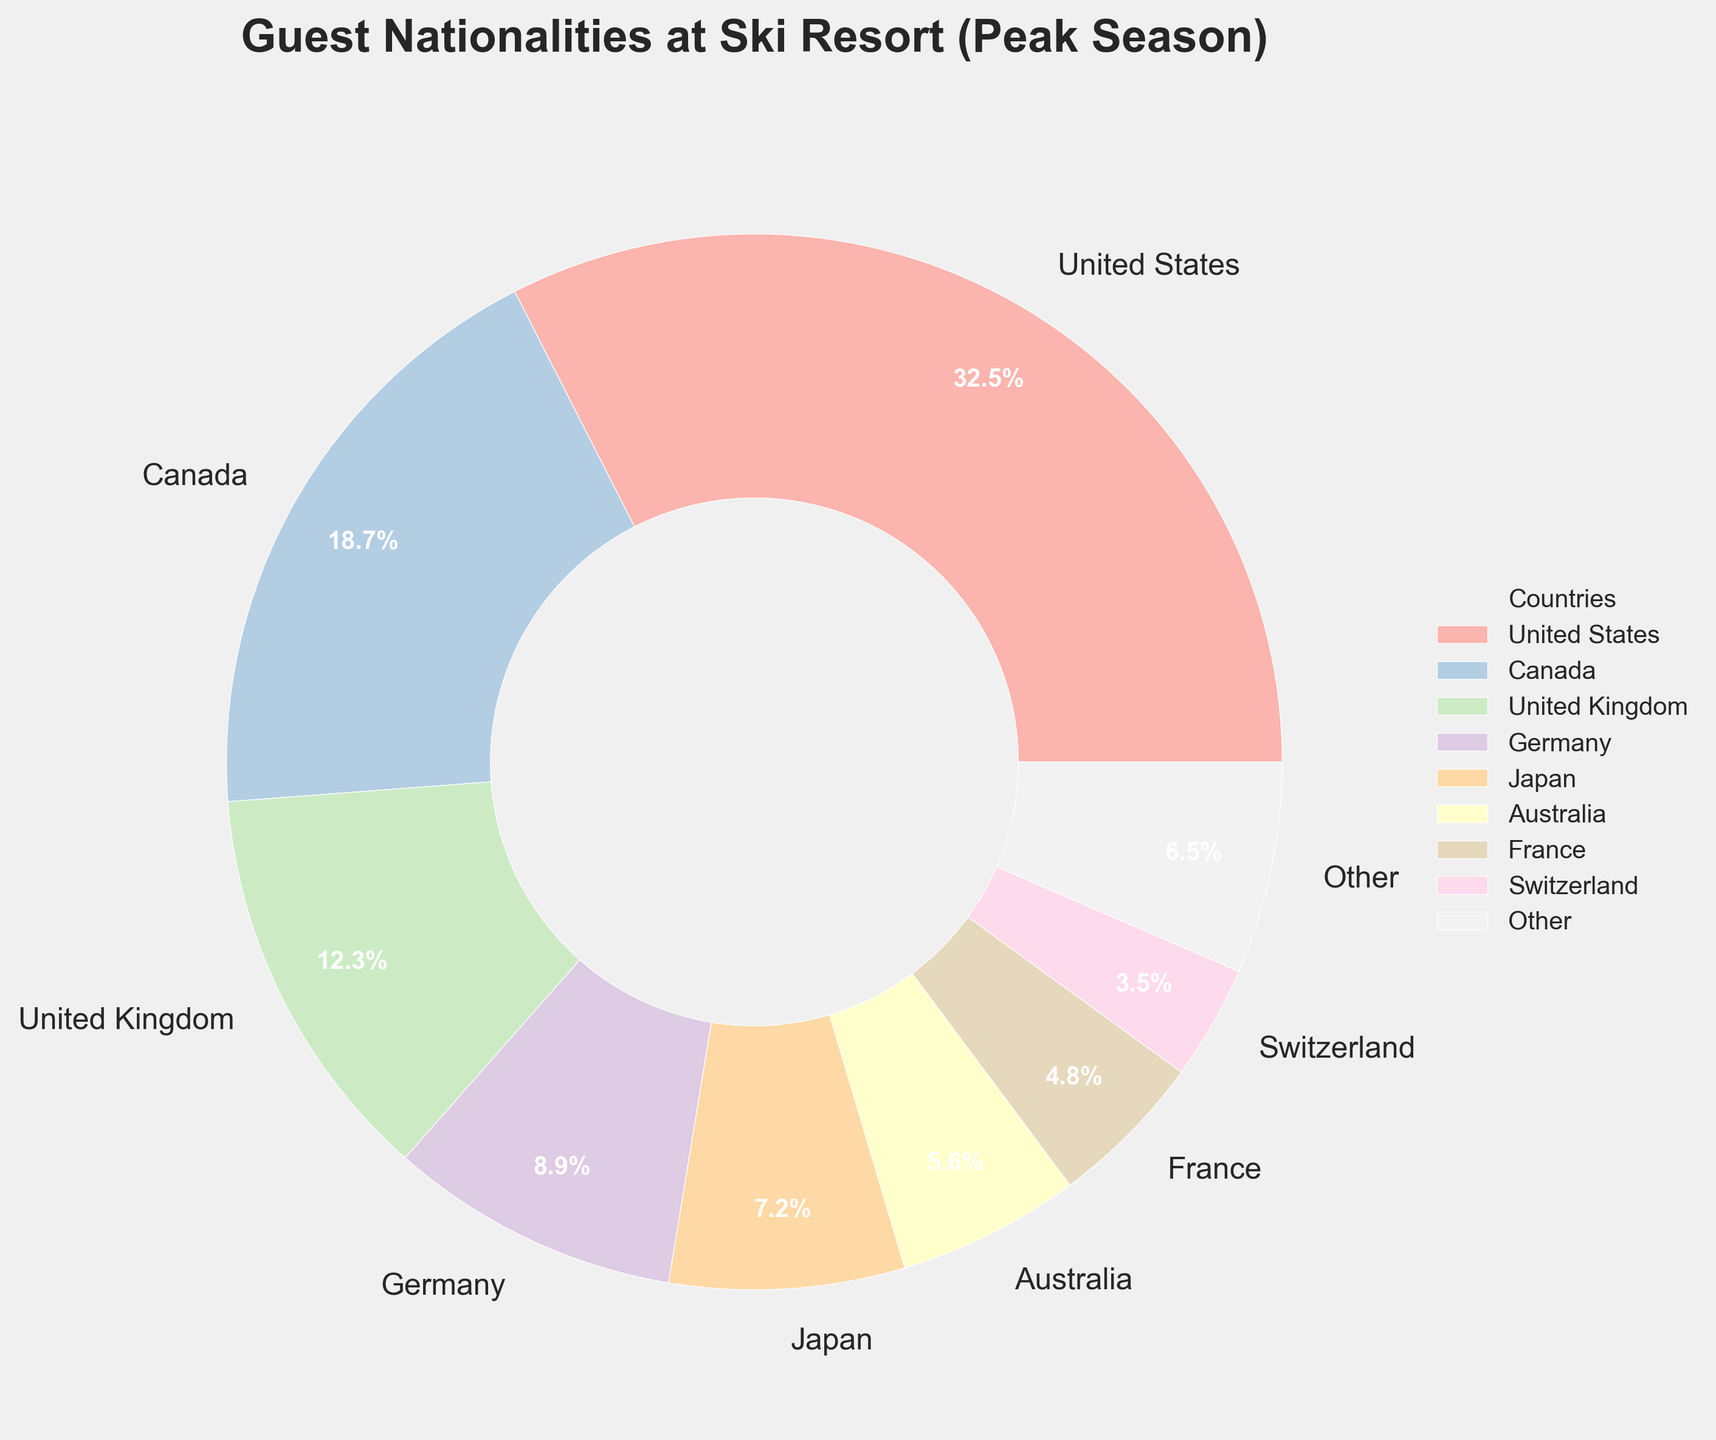What's the proportion of guests from Canada compared to those from the United States? To determine the proportion of guests from Canada compared to those from the United States, we compare their respective percentages. Canada's percentage is 18.7%, while the United States' percentage is 32.5%. The proportion is 18.7/32.5.
Answer: Approximately 0.575 Which countries represent less than 3% of the guest nationalities? Filter out the countries with percentages less than 3% from the data, which include Russia, Netherlands, Sweden, and Norway.
Answer: Russia, Netherlands, Sweden, Norway How does the percentage of guests from Germany compare to that from the United Kingdom? From the figure, Germany's percentage is 8.9%, while the United Kingdom's percentage is 12.3%. Comparing these, the United Kingdom has a higher percentage than Germany.
Answer: United Kingdom has a higher percentage What percentage of the guests come from countries categorized as "Other"? The "Other" category includes all countries with individual percentages less than 3%. According to the data, the total percentage of these countries sums to 2.7 + 1.8 + 1.2 + 0.8 = 6.5%.
Answer: 6.5% Which country has a larger guest percentage, Japan or Australia? From the figure, Japan's percentage is 7.2%, whereas Australia's percentage is 5.6%. By comparing these values, we see that Japan has a larger guest percentage.
Answer: Japan What is the combined percentage of guests from France and Switzerland? Add the percentages of France and Switzerland. France's percentage is 4.8%, and Switzerland's is 3.5%. So, 4.8% + 3.5% = 8.3%.
Answer: 8.3% Which country has the smallest guest percentage making it to the filtered list on the pie chart? The filtered list includes countries with percentages of at least 3%, so the smallest percentage in this filtered list is Switzerland with 3.5%.
Answer: Switzerland How much higher is the guest percentage from the United States compared to the United Kingdom? Subtract the United Kingdom's percentage from the United States' percentage. 32.5% - 12.3% = 20.2%. Therefore, the United States' percentage is 20.2% higher than the United Kingdom's.
Answer: 20.2% What is the average guest percentage of the top three countries? To find the average percentage of the top three countries (United States, Canada, and United Kingdom), add their percentages and divide by 3. (32.5% + 18.7% + 12.3%) / 3 = 63.5% / 3 = 21.17%.
Answer: 21.17% What is the difference in guest percentages between France and Japan? Subtract France's percentage from Japan's. Japan's percentage is 7.2%, and France's is 4.8%. So, 7.2% - 4.8% = 2.4%.
Answer: 2.4% 